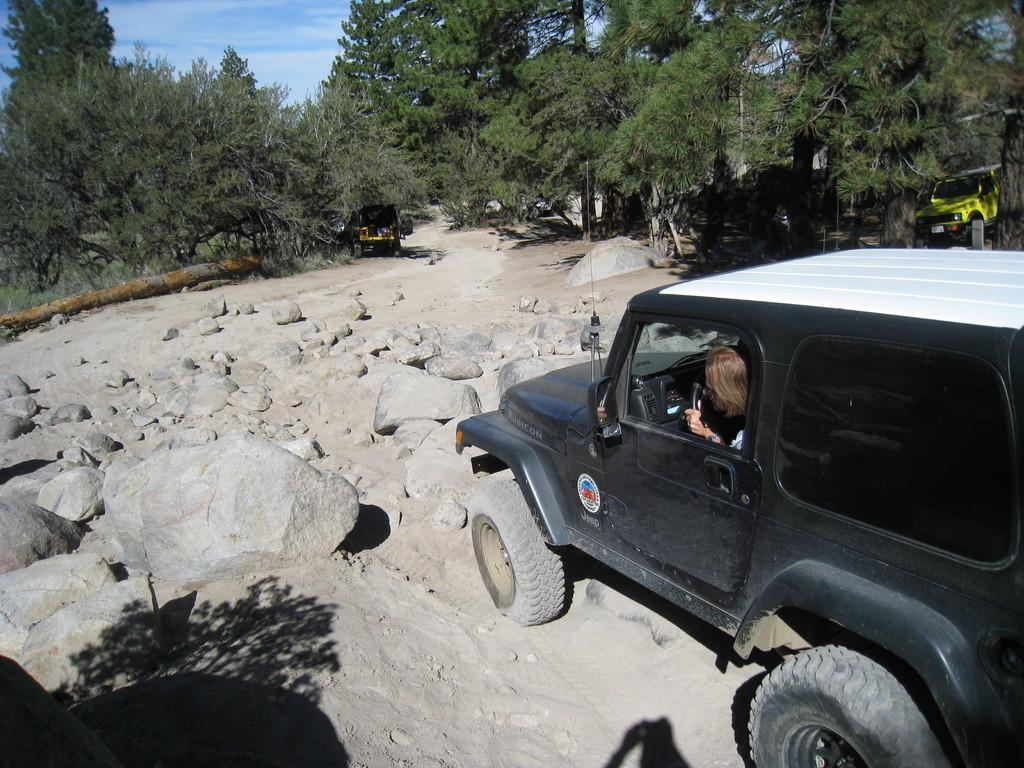In one or two sentences, can you explain what this image depicts? In the picture we can see a sand surface on it, we can see a rock and near it, we can see a] jeep which is black in color with a man sitting in it and in the background also we can see two vehicles near the trees and behind it we can see a sky with clouds. 